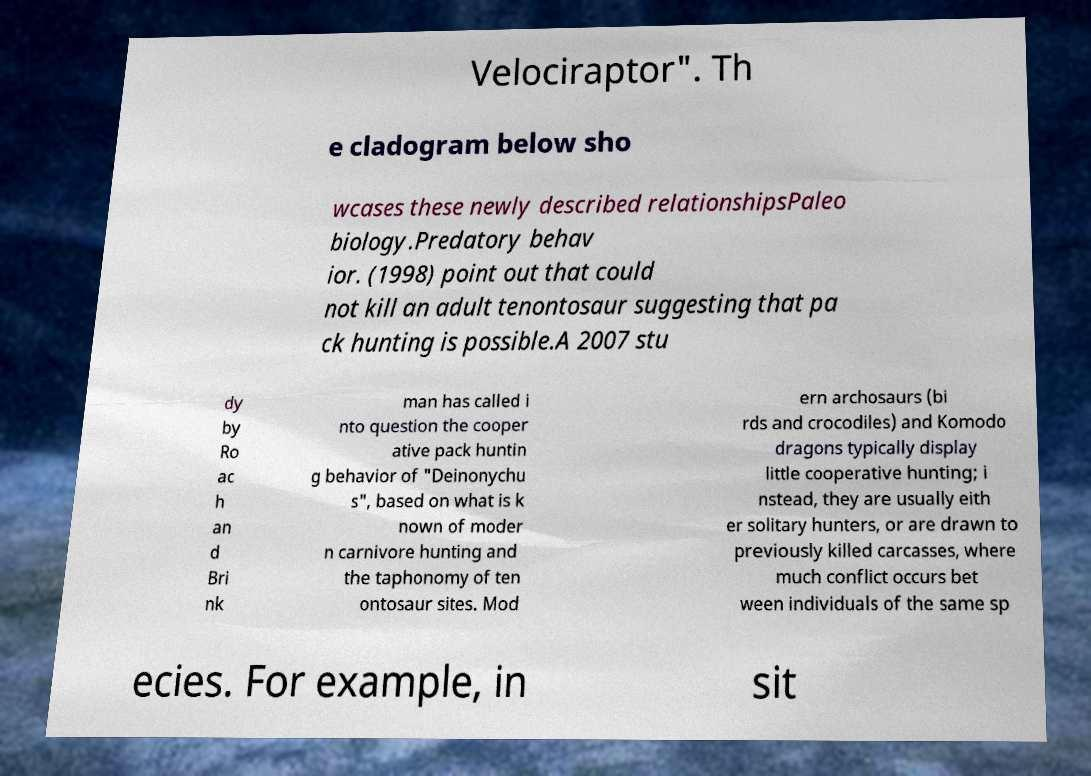Can you accurately transcribe the text from the provided image for me? Velociraptor". Th e cladogram below sho wcases these newly described relationshipsPaleo biology.Predatory behav ior. (1998) point out that could not kill an adult tenontosaur suggesting that pa ck hunting is possible.A 2007 stu dy by Ro ac h an d Bri nk man has called i nto question the cooper ative pack huntin g behavior of "Deinonychu s", based on what is k nown of moder n carnivore hunting and the taphonomy of ten ontosaur sites. Mod ern archosaurs (bi rds and crocodiles) and Komodo dragons typically display little cooperative hunting; i nstead, they are usually eith er solitary hunters, or are drawn to previously killed carcasses, where much conflict occurs bet ween individuals of the same sp ecies. For example, in sit 